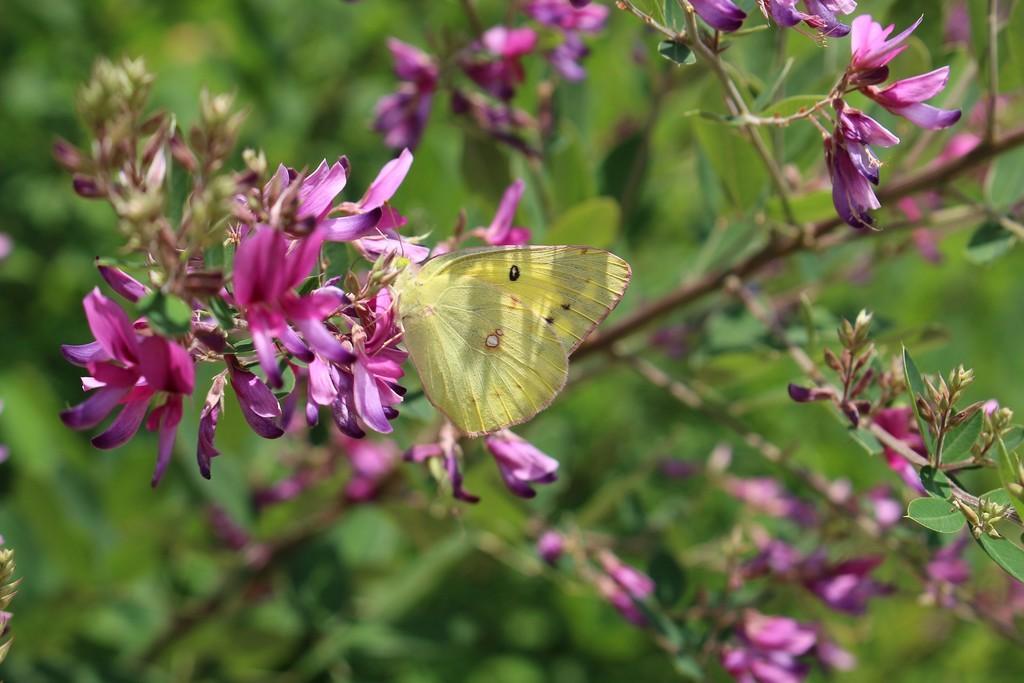Could you give a brief overview of what you see in this image? In this picture I can see there are few pink color flowers and there are few buds, there is a green color butterfly on the flowers. In the backdrop, it looks like there are plants and the backdrop is blurred. 